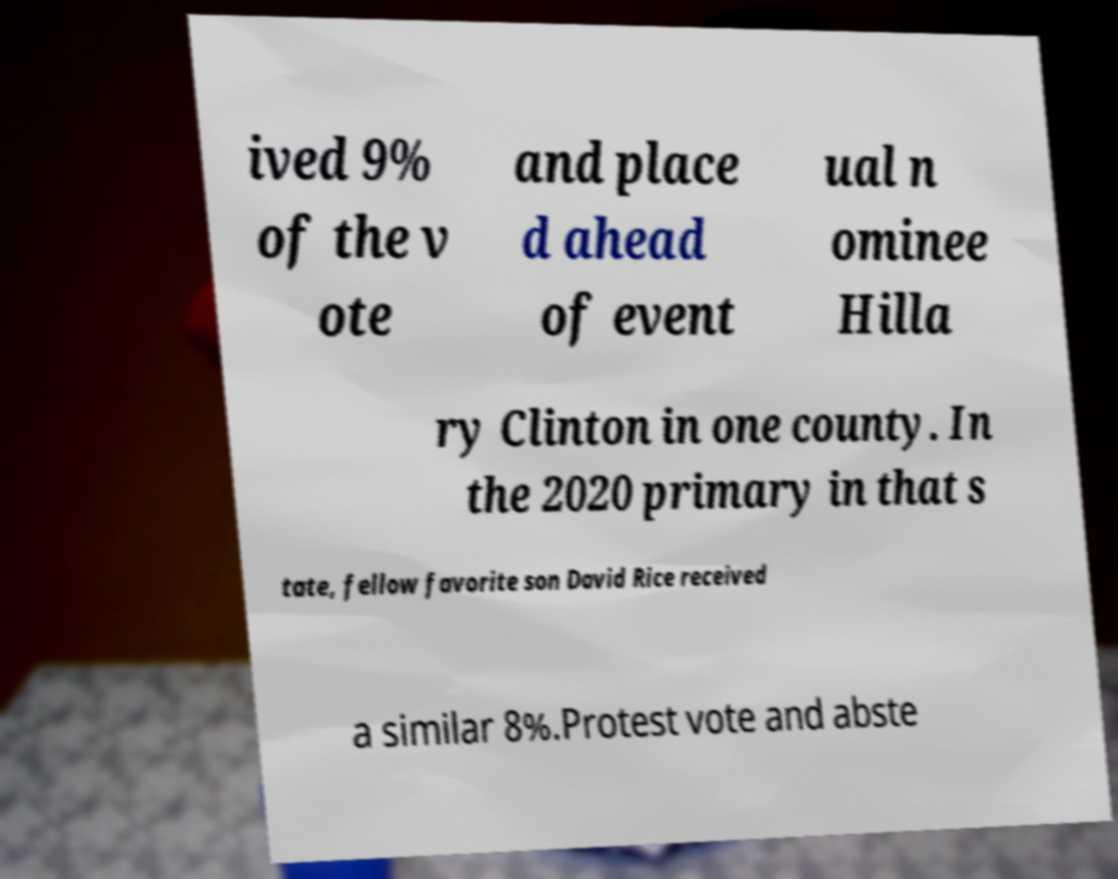Please identify and transcribe the text found in this image. ived 9% of the v ote and place d ahead of event ual n ominee Hilla ry Clinton in one county. In the 2020 primary in that s tate, fellow favorite son David Rice received a similar 8%.Protest vote and abste 